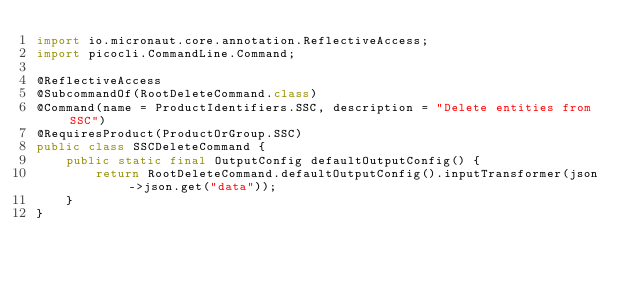Convert code to text. <code><loc_0><loc_0><loc_500><loc_500><_Java_>import io.micronaut.core.annotation.ReflectiveAccess;
import picocli.CommandLine.Command;

@ReflectiveAccess
@SubcommandOf(RootDeleteCommand.class)
@Command(name = ProductIdentifiers.SSC, description = "Delete entities from SSC")
@RequiresProduct(ProductOrGroup.SSC)
public class SSCDeleteCommand {
	public static final OutputConfig defaultOutputConfig() {
		return RootDeleteCommand.defaultOutputConfig().inputTransformer(json->json.get("data"));
	}
}</code> 